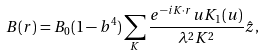Convert formula to latex. <formula><loc_0><loc_0><loc_500><loc_500>B ( r ) = B _ { 0 } ( 1 - b ^ { 4 } ) \sum _ { K } \frac { e ^ { - i K \cdot r } u K _ { 1 } ( u ) } { \lambda ^ { 2 } K ^ { 2 } } \hat { z } ,</formula> 